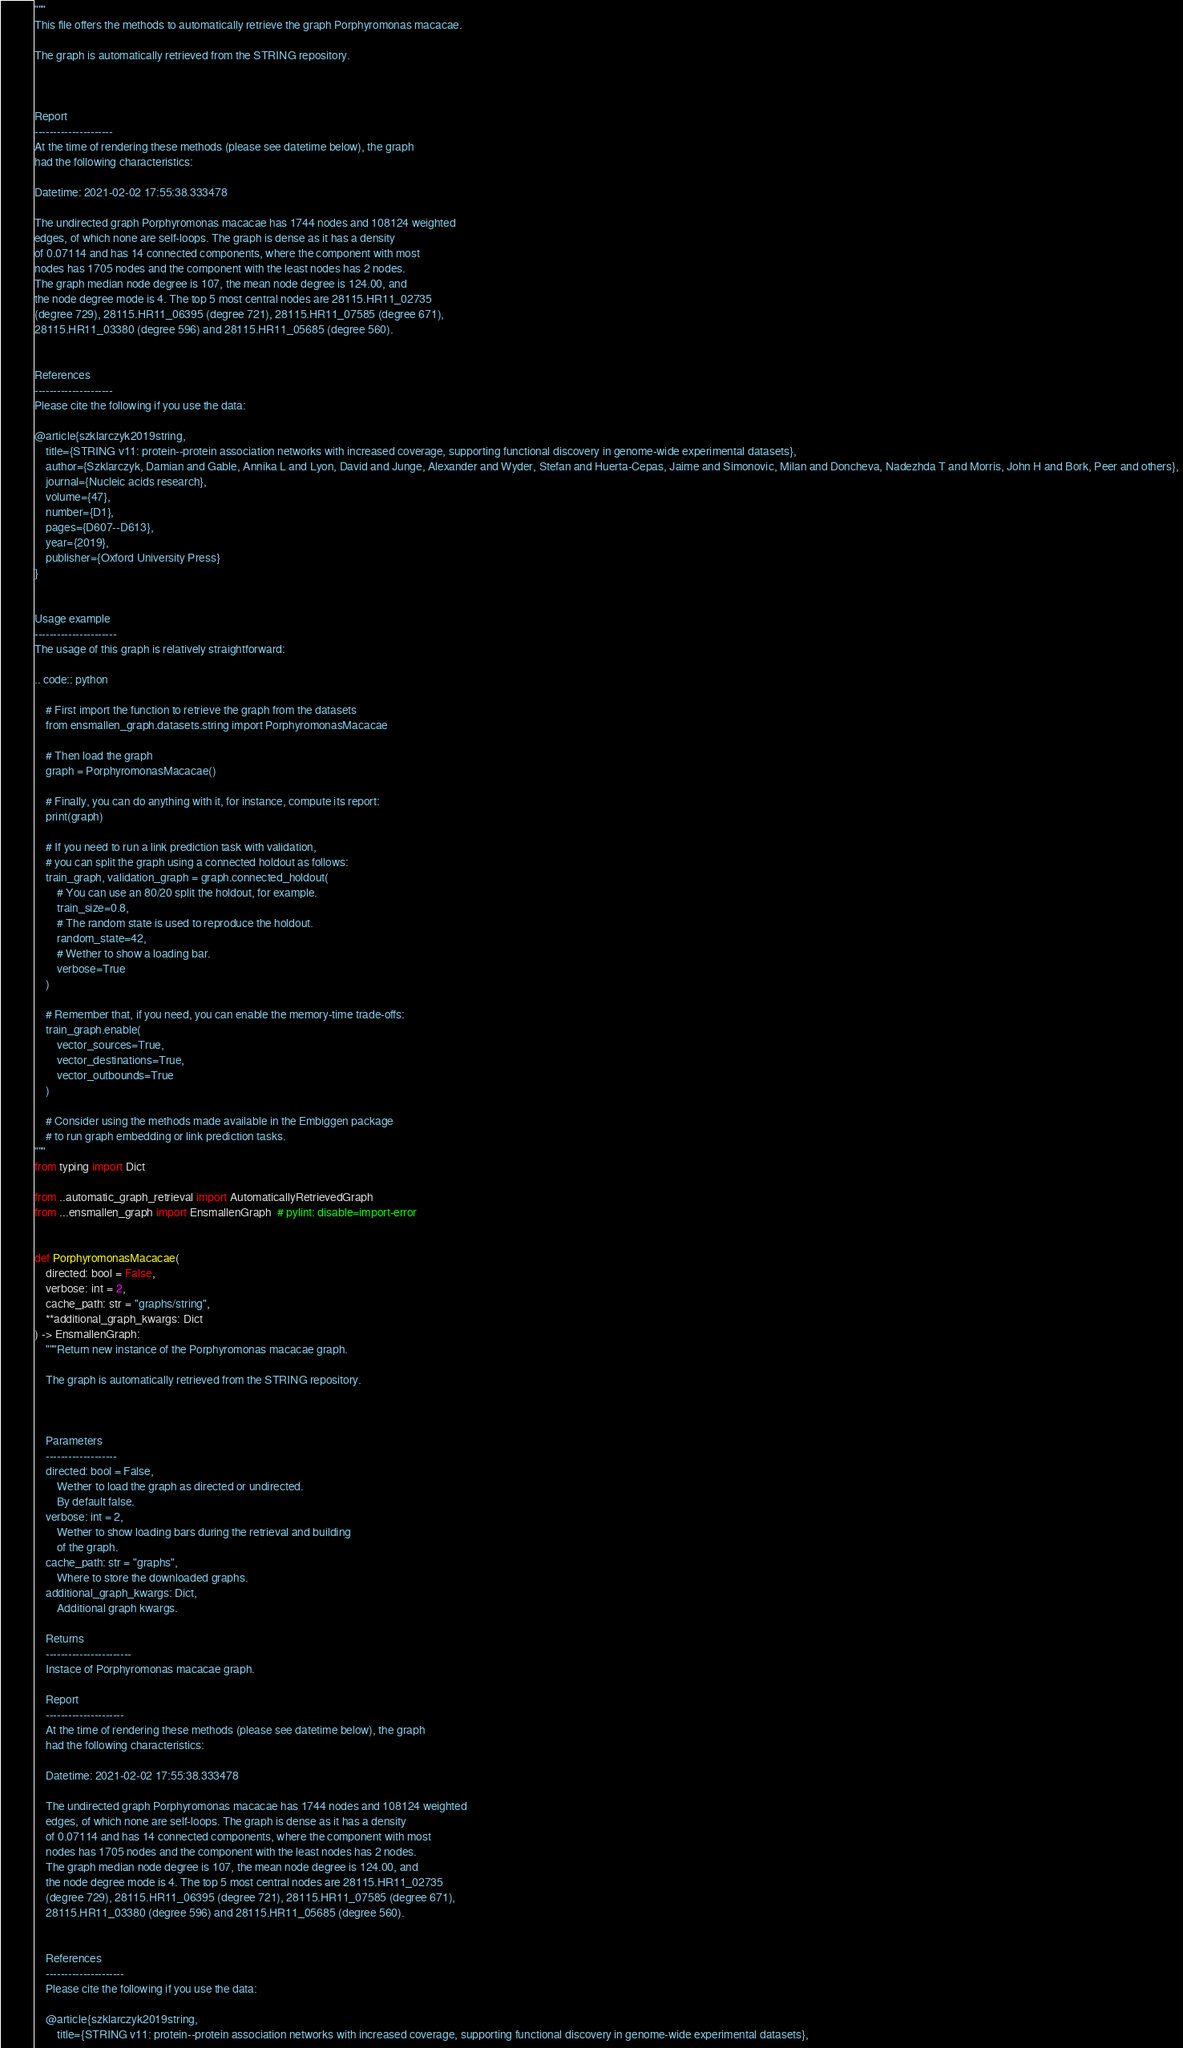Convert code to text. <code><loc_0><loc_0><loc_500><loc_500><_Python_>"""
This file offers the methods to automatically retrieve the graph Porphyromonas macacae.

The graph is automatically retrieved from the STRING repository. 



Report
---------------------
At the time of rendering these methods (please see datetime below), the graph
had the following characteristics:

Datetime: 2021-02-02 17:55:38.333478

The undirected graph Porphyromonas macacae has 1744 nodes and 108124 weighted
edges, of which none are self-loops. The graph is dense as it has a density
of 0.07114 and has 14 connected components, where the component with most
nodes has 1705 nodes and the component with the least nodes has 2 nodes.
The graph median node degree is 107, the mean node degree is 124.00, and
the node degree mode is 4. The top 5 most central nodes are 28115.HR11_02735
(degree 729), 28115.HR11_06395 (degree 721), 28115.HR11_07585 (degree 671),
28115.HR11_03380 (degree 596) and 28115.HR11_05685 (degree 560).


References
---------------------
Please cite the following if you use the data:

@article{szklarczyk2019string,
    title={STRING v11: protein--protein association networks with increased coverage, supporting functional discovery in genome-wide experimental datasets},
    author={Szklarczyk, Damian and Gable, Annika L and Lyon, David and Junge, Alexander and Wyder, Stefan and Huerta-Cepas, Jaime and Simonovic, Milan and Doncheva, Nadezhda T and Morris, John H and Bork, Peer and others},
    journal={Nucleic acids research},
    volume={47},
    number={D1},
    pages={D607--D613},
    year={2019},
    publisher={Oxford University Press}
}


Usage example
----------------------
The usage of this graph is relatively straightforward:

.. code:: python

    # First import the function to retrieve the graph from the datasets
    from ensmallen_graph.datasets.string import PorphyromonasMacacae

    # Then load the graph
    graph = PorphyromonasMacacae()

    # Finally, you can do anything with it, for instance, compute its report:
    print(graph)

    # If you need to run a link prediction task with validation,
    # you can split the graph using a connected holdout as follows:
    train_graph, validation_graph = graph.connected_holdout(
        # You can use an 80/20 split the holdout, for example.
        train_size=0.8,
        # The random state is used to reproduce the holdout.
        random_state=42,
        # Wether to show a loading bar.
        verbose=True
    )

    # Remember that, if you need, you can enable the memory-time trade-offs:
    train_graph.enable(
        vector_sources=True,
        vector_destinations=True,
        vector_outbounds=True
    )

    # Consider using the methods made available in the Embiggen package
    # to run graph embedding or link prediction tasks.
"""
from typing import Dict

from ..automatic_graph_retrieval import AutomaticallyRetrievedGraph
from ...ensmallen_graph import EnsmallenGraph  # pylint: disable=import-error


def PorphyromonasMacacae(
    directed: bool = False,
    verbose: int = 2,
    cache_path: str = "graphs/string",
    **additional_graph_kwargs: Dict
) -> EnsmallenGraph:
    """Return new instance of the Porphyromonas macacae graph.

    The graph is automatically retrieved from the STRING repository. 

	

    Parameters
    -------------------
    directed: bool = False,
        Wether to load the graph as directed or undirected.
        By default false.
    verbose: int = 2,
        Wether to show loading bars during the retrieval and building
        of the graph.
    cache_path: str = "graphs",
        Where to store the downloaded graphs.
    additional_graph_kwargs: Dict,
        Additional graph kwargs.

    Returns
    -----------------------
    Instace of Porphyromonas macacae graph.

	Report
	---------------------
	At the time of rendering these methods (please see datetime below), the graph
	had the following characteristics:
	
	Datetime: 2021-02-02 17:55:38.333478
	
	The undirected graph Porphyromonas macacae has 1744 nodes and 108124 weighted
	edges, of which none are self-loops. The graph is dense as it has a density
	of 0.07114 and has 14 connected components, where the component with most
	nodes has 1705 nodes and the component with the least nodes has 2 nodes.
	The graph median node degree is 107, the mean node degree is 124.00, and
	the node degree mode is 4. The top 5 most central nodes are 28115.HR11_02735
	(degree 729), 28115.HR11_06395 (degree 721), 28115.HR11_07585 (degree 671),
	28115.HR11_03380 (degree 596) and 28115.HR11_05685 (degree 560).
	

	References
	---------------------
	Please cite the following if you use the data:
	
	@article{szklarczyk2019string,
	    title={STRING v11: protein--protein association networks with increased coverage, supporting functional discovery in genome-wide experimental datasets},</code> 